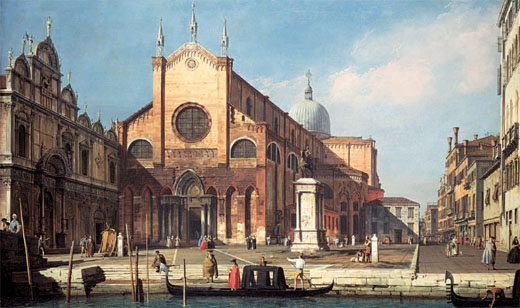What kind of daily activities do you think are happening in the foreground? In the foreground, we're likely witnessing a bustling square, typical of Venetian life. People might be engaging in casual conversations, strolling through the market, perhaps bartering goods. Others could be waiting for gondola rides by the canal, which adds a touch of Venice’s unique charm. The blend of activities paints a lively, communal atmosphere, where residents and visitors alike participate in the vibrant tapestry of daily life. 